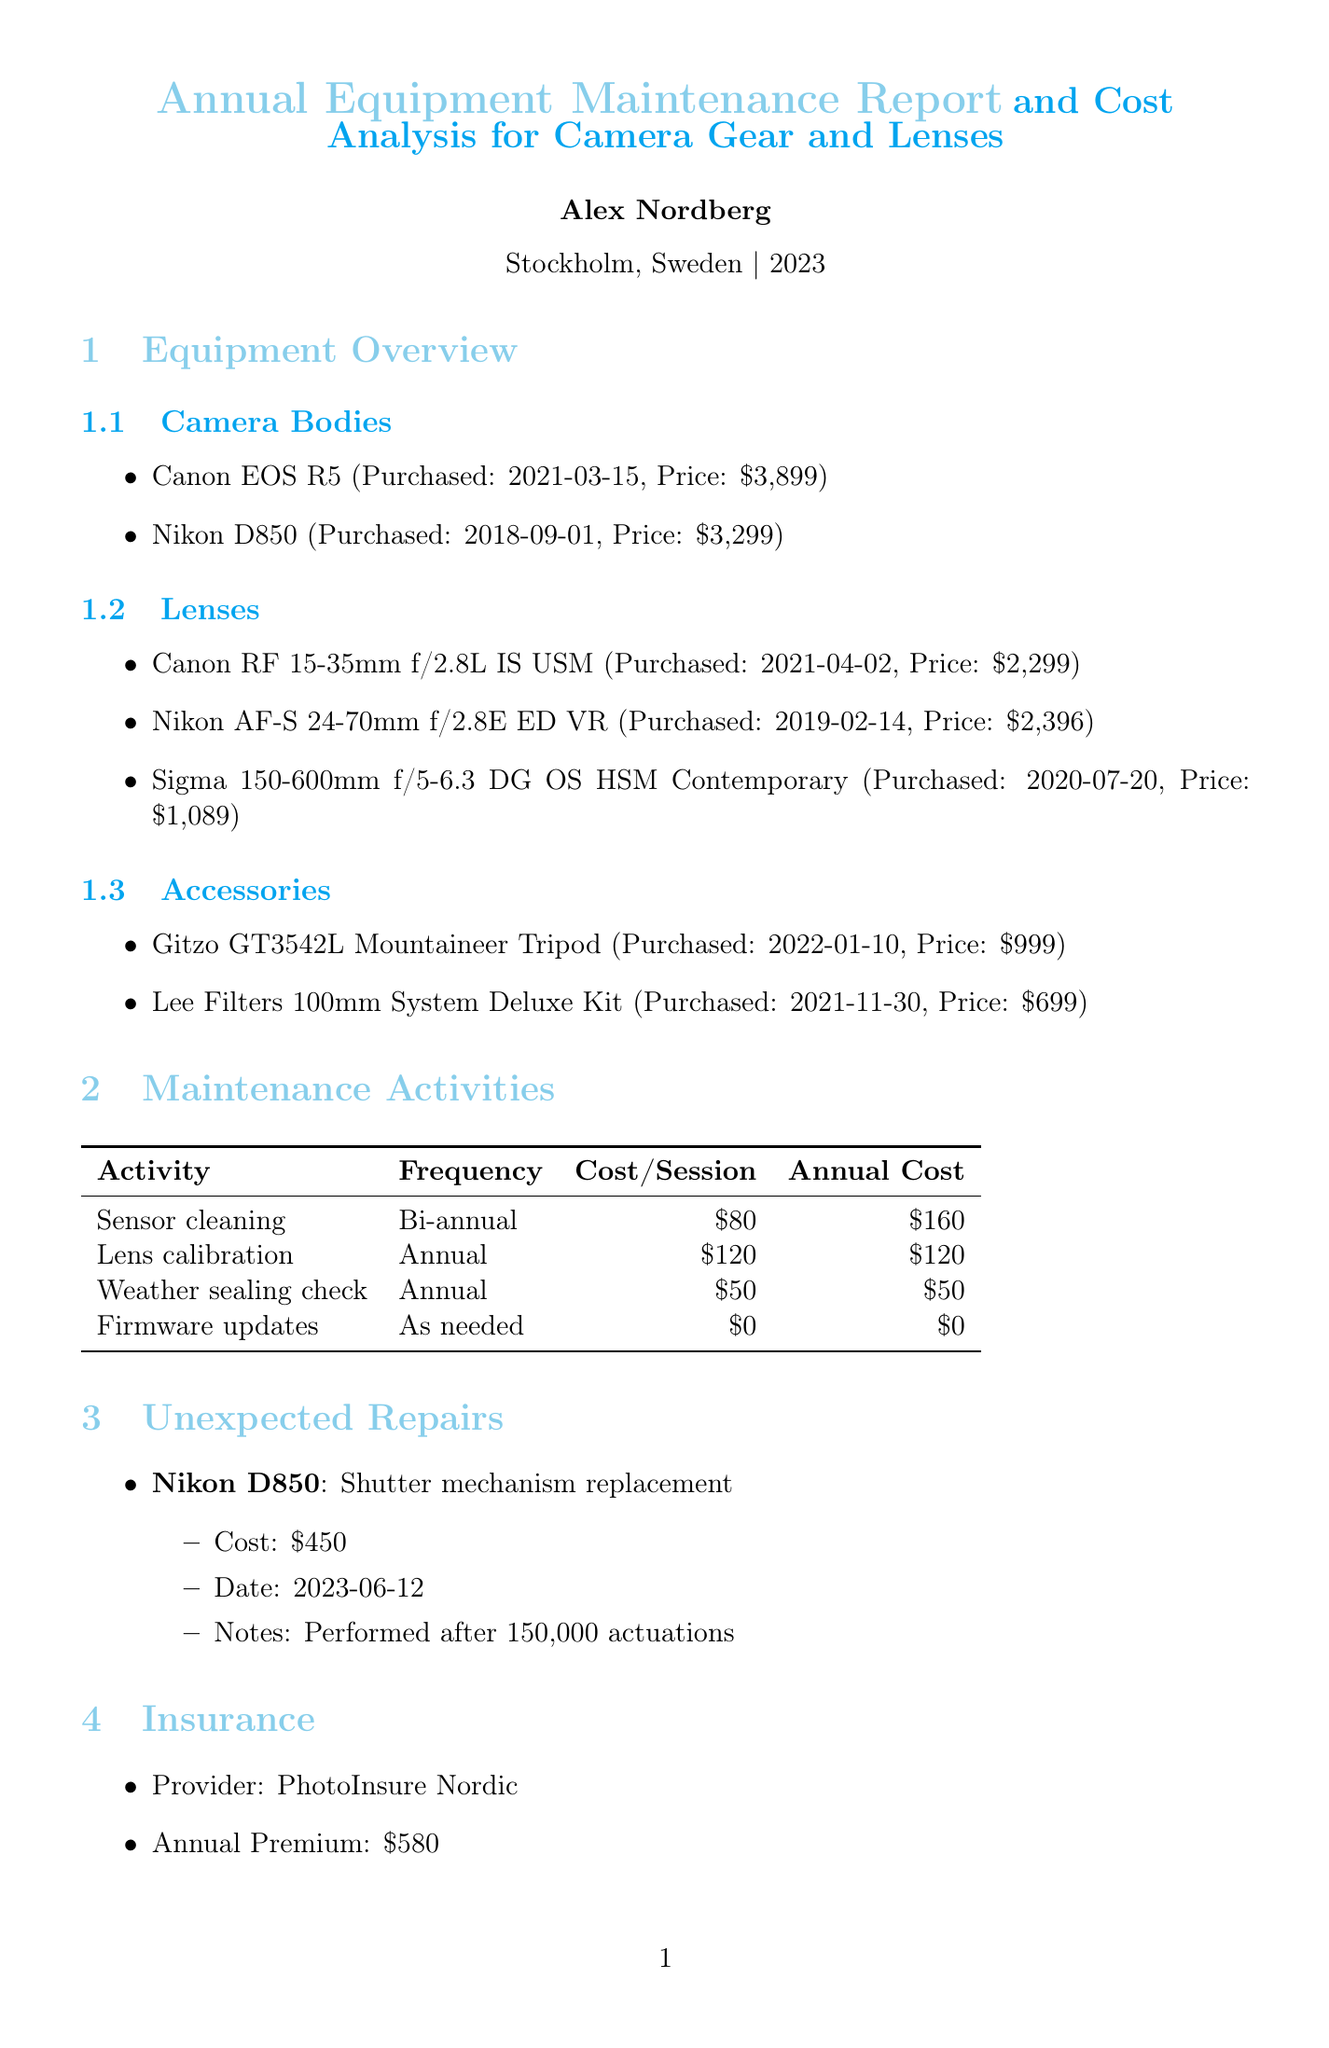what is the purchase price of the Canon EOS R5? The Canon EOS R5's purchase price is listed in the equipment overview section of the document.
Answer: $3,899 how often is lens calibration performed? The frequency of lens calibration is stated in the maintenance activities section as "Annual."
Answer: Annual what is the total annual cost for routine maintenance? The total annual cost for routine maintenance is highlighted in the annual cost summary table.
Answer: $330 who performed the sensor cleaning? The maintenance activities section notes who performed the sensor cleaning.
Answer: CameraCare Stockholm what is the cost of the unexpected repair for the Nikon D850? The document specifies the cost of the unexpected repair for the Nikon D850 in the unexpected repairs section.
Answer: $450 how much is the annual premium for insurance? The insurance section lists the annual premium explicitly.
Answer: $580 what are the protection measures used during the Caribbean trip? The travel considerations section includes gear protection measures for the trip to St. Lucia.
Answer: Pelican 1510 hard case, Silica gel packets, ThinkTank rain covers how much was spent on climate adaptation costs? The climate adaptation costs are totaled within the adaptation costs section of the document.
Answer: $284 what is the estimated cost of the Sony FE 100-400mm f/4.5-5.6 GM OSS? The future equipment considerations section provides the estimated cost for this lens.
Answer: $2,498 